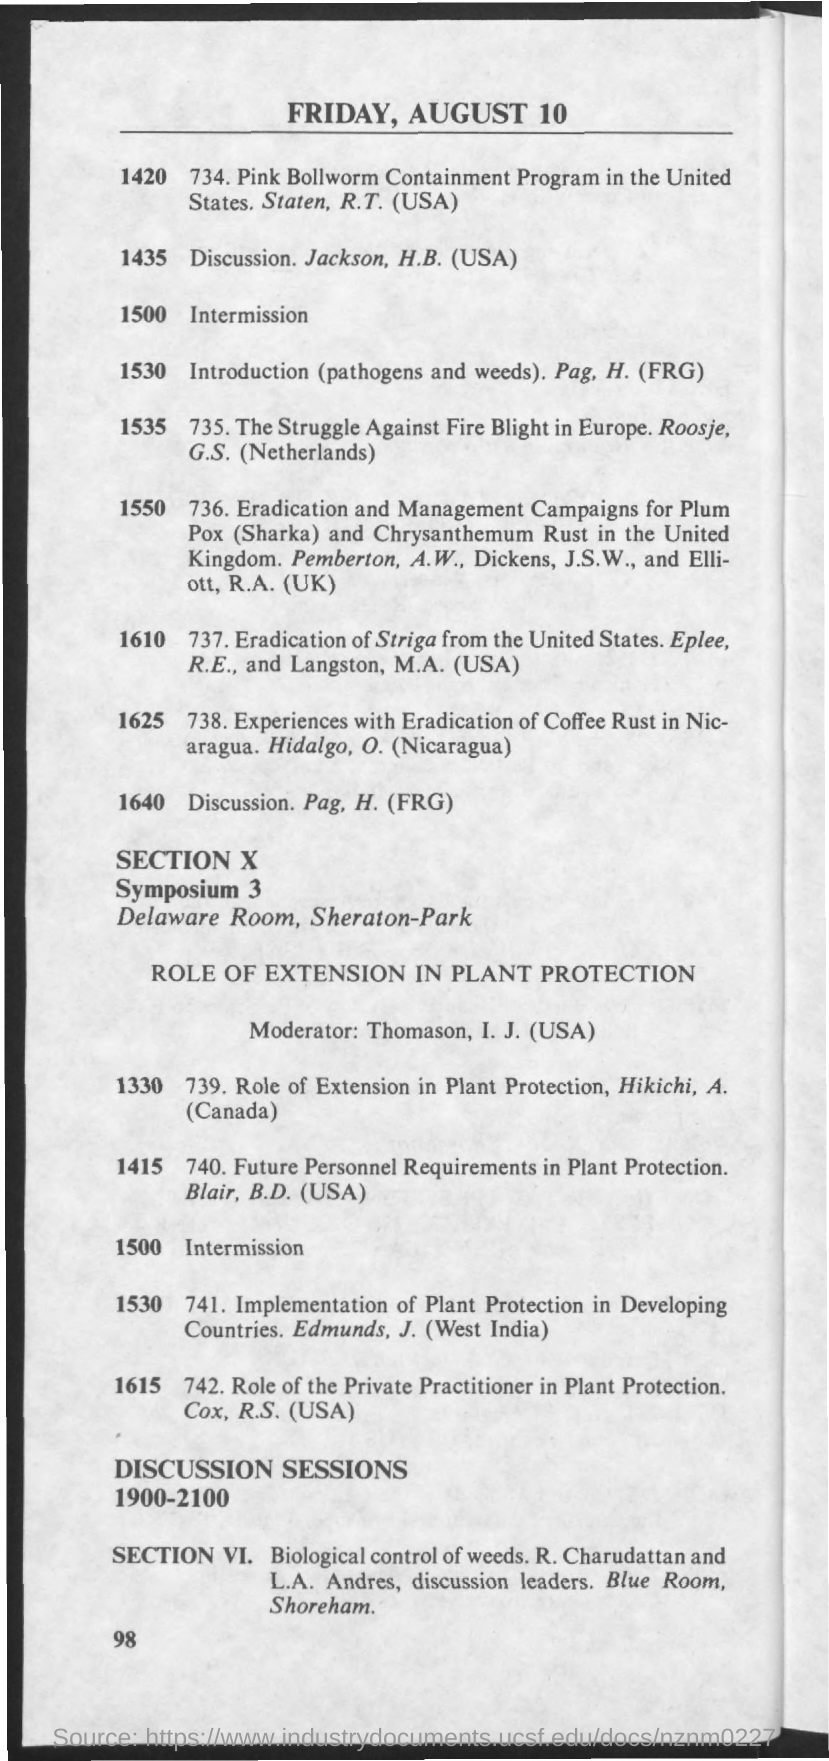Highlight a few significant elements in this photo. The topic on page 1640 is 'discussion.' The date mentioned in the document is Friday, August 10. 